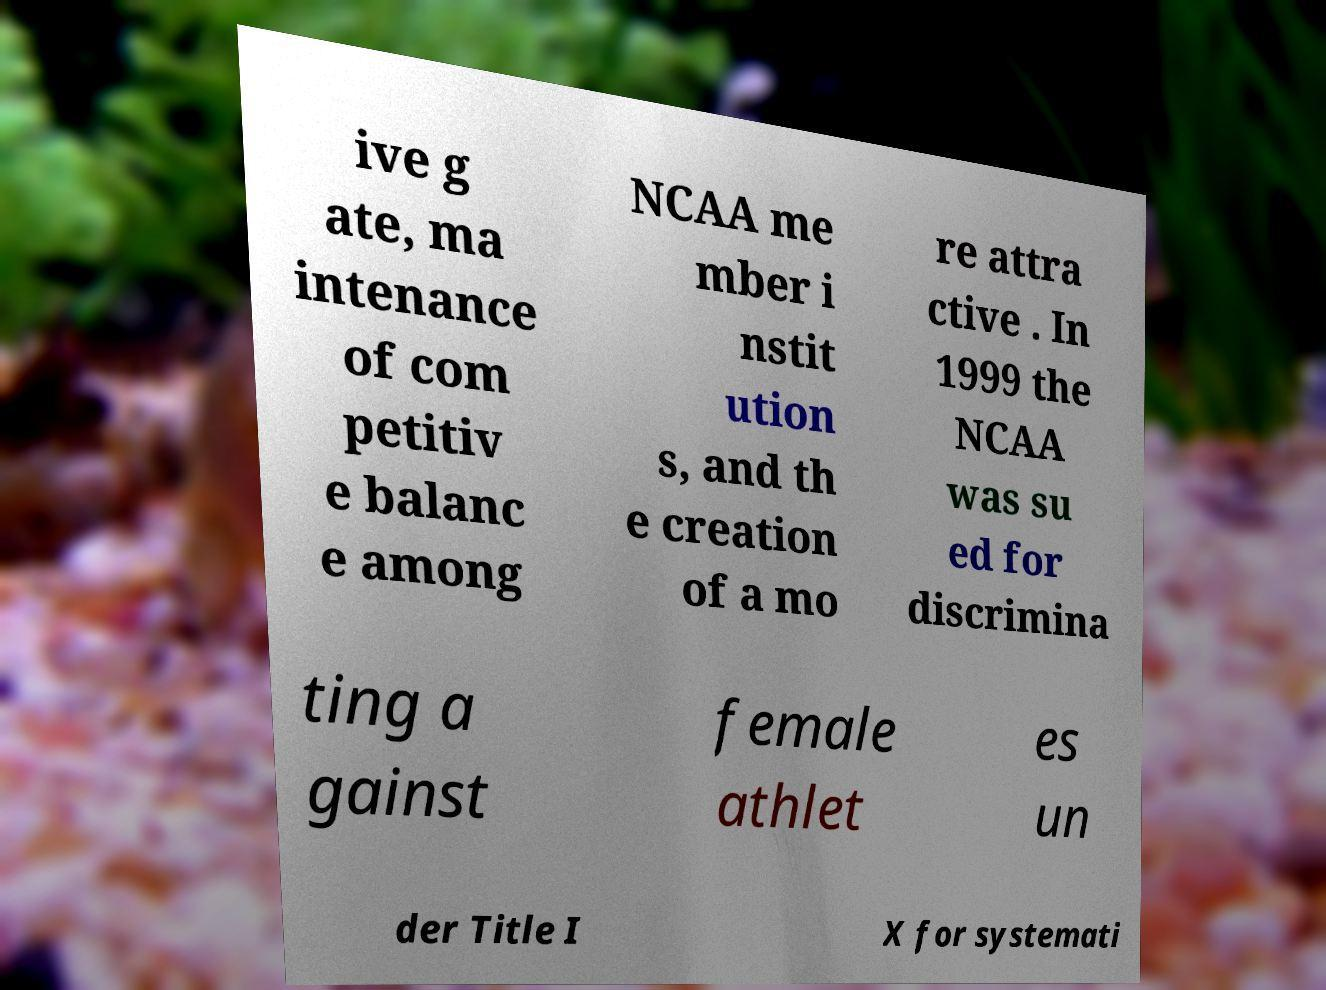What messages or text are displayed in this image? I need them in a readable, typed format. ive g ate, ma intenance of com petitiv e balanc e among NCAA me mber i nstit ution s, and th e creation of a mo re attra ctive . In 1999 the NCAA was su ed for discrimina ting a gainst female athlet es un der Title I X for systemati 